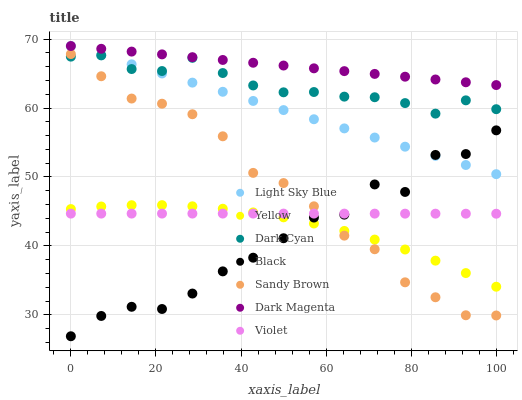Does Black have the minimum area under the curve?
Answer yes or no. Yes. Does Dark Magenta have the maximum area under the curve?
Answer yes or no. Yes. Does Yellow have the minimum area under the curve?
Answer yes or no. No. Does Yellow have the maximum area under the curve?
Answer yes or no. No. Is Light Sky Blue the smoothest?
Answer yes or no. Yes. Is Black the roughest?
Answer yes or no. Yes. Is Yellow the smoothest?
Answer yes or no. No. Is Yellow the roughest?
Answer yes or no. No. Does Black have the lowest value?
Answer yes or no. Yes. Does Yellow have the lowest value?
Answer yes or no. No. Does Light Sky Blue have the highest value?
Answer yes or no. Yes. Does Yellow have the highest value?
Answer yes or no. No. Is Sandy Brown less than Dark Magenta?
Answer yes or no. Yes. Is Dark Cyan greater than Black?
Answer yes or no. Yes. Does Black intersect Yellow?
Answer yes or no. Yes. Is Black less than Yellow?
Answer yes or no. No. Is Black greater than Yellow?
Answer yes or no. No. Does Sandy Brown intersect Dark Magenta?
Answer yes or no. No. 